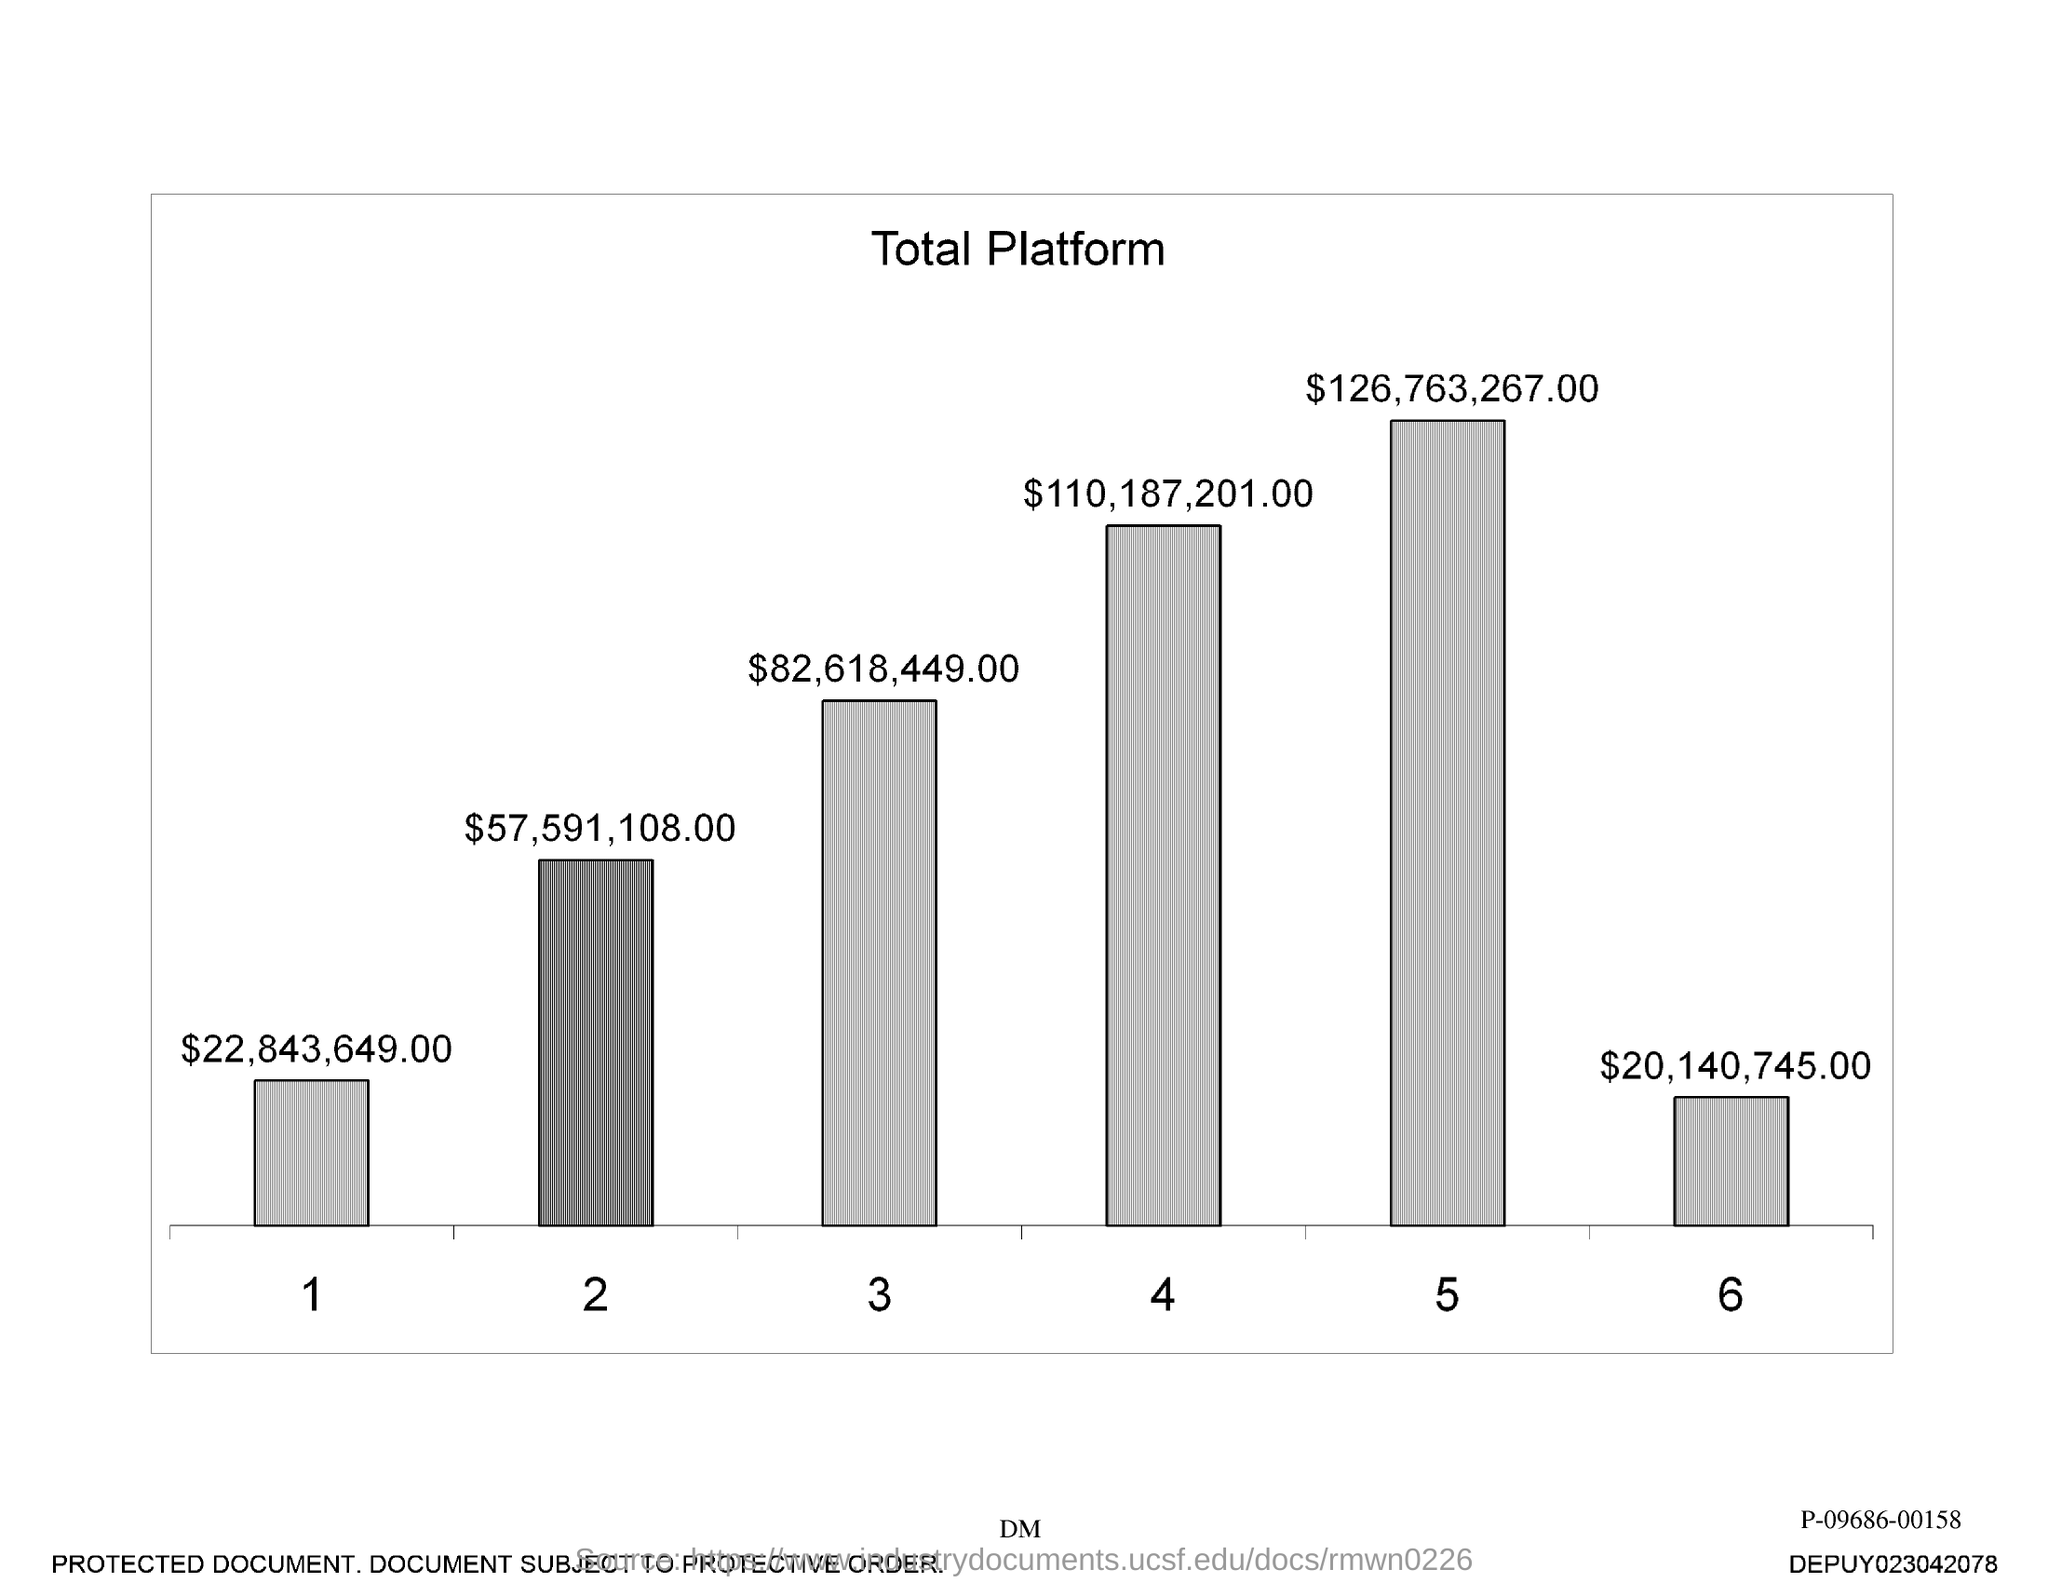What is the title given?
Ensure brevity in your answer.  Total Platform. What is the value of the bar 3?
Provide a succinct answer. $82,618,449.00. 